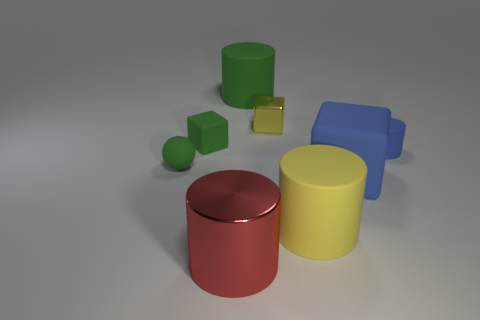Subtract all matte cubes. How many cubes are left? 1 Subtract all balls. How many objects are left? 7 Add 1 green matte objects. How many green matte objects exist? 4 Add 2 purple balls. How many objects exist? 10 Subtract all yellow cubes. How many cubes are left? 2 Subtract 0 gray cubes. How many objects are left? 8 Subtract 2 blocks. How many blocks are left? 1 Subtract all purple spheres. Subtract all purple blocks. How many spheres are left? 1 Subtract all yellow cylinders. How many red spheres are left? 0 Subtract all tiny blue objects. Subtract all large yellow cylinders. How many objects are left? 6 